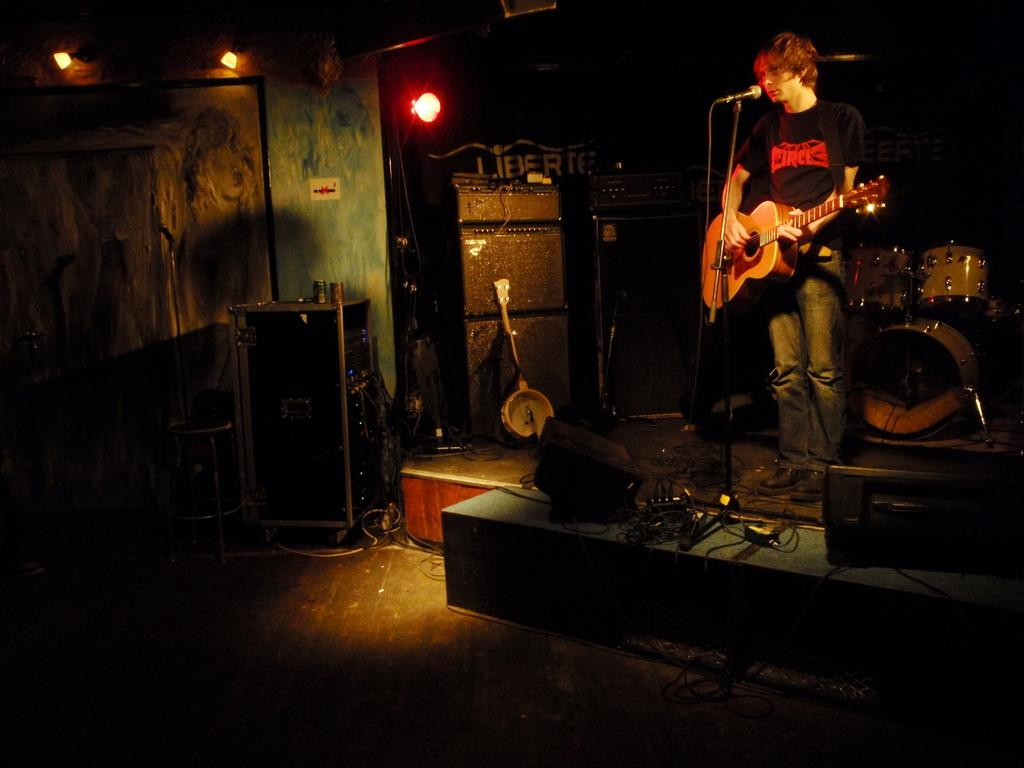What can be seen in the image that produces light? There are lights visible in the image. What is the man in the image doing? The man is playing a guitar and singing in the image. What object is the man using to amplify his voice? There is a microphone in the image. What other musical instruments are present in the image? There are musical instruments in the image, but the specific instruments are not mentioned in the facts. What object in the image might be used for storage? There is a box in the image that might be used for storage. What objects in the image are used for amplifying sound? There are speakers in the image that are used for amplifying sound. What level of the mine is the man playing the guitar in the image? There is no mention of a mine in the image or the facts provided. The man is playing the guitar in a setting with lights, a microphone, musical instruments, a box, and speakers. 